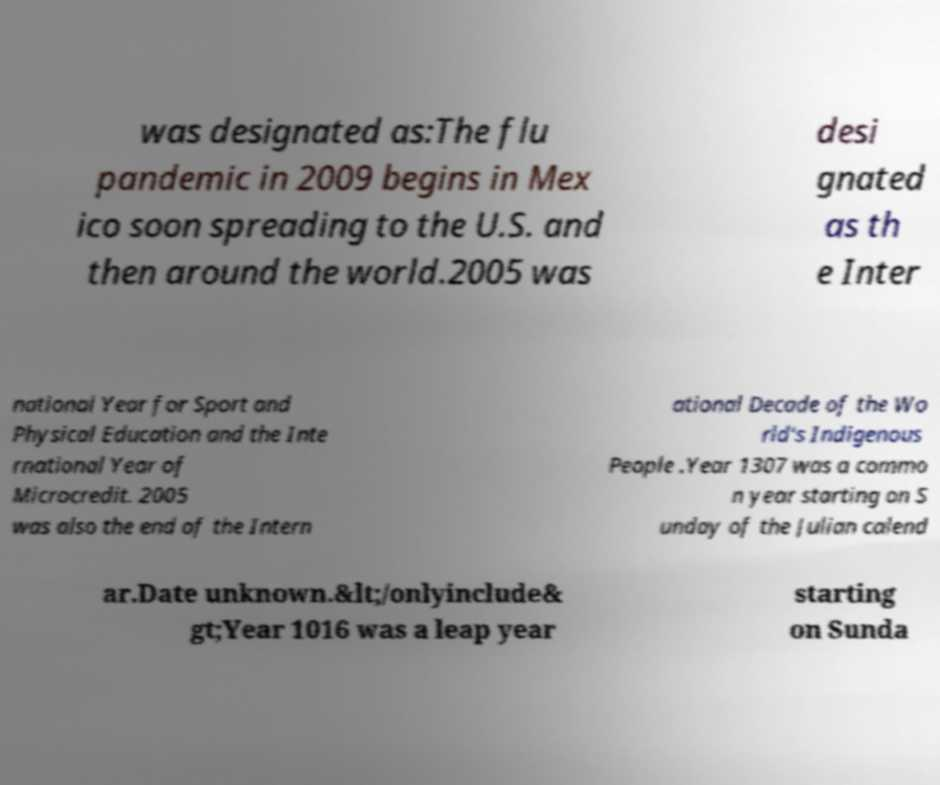Can you accurately transcribe the text from the provided image for me? was designated as:The flu pandemic in 2009 begins in Mex ico soon spreading to the U.S. and then around the world.2005 was desi gnated as th e Inter national Year for Sport and Physical Education and the Inte rnational Year of Microcredit. 2005 was also the end of the Intern ational Decade of the Wo rld's Indigenous People .Year 1307 was a commo n year starting on S unday of the Julian calend ar.Date unknown.&lt;/onlyinclude& gt;Year 1016 was a leap year starting on Sunda 